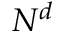Convert formula to latex. <formula><loc_0><loc_0><loc_500><loc_500>N ^ { d }</formula> 